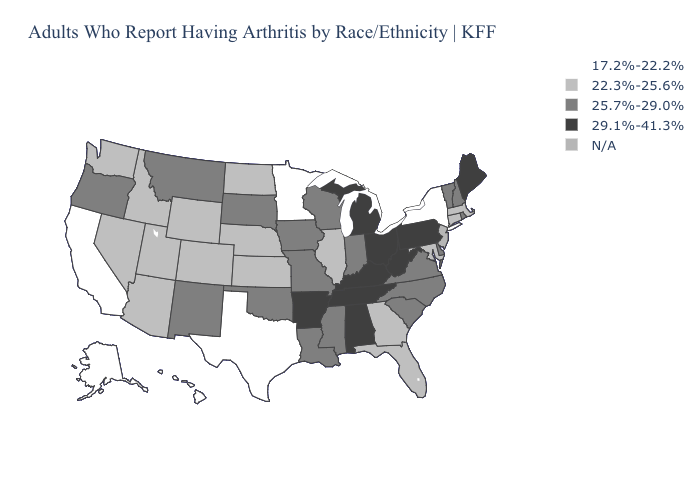Among the states that border Vermont , which have the lowest value?
Answer briefly. New York. Which states hav the highest value in the MidWest?
Quick response, please. Michigan, Ohio. Which states hav the highest value in the South?
Keep it brief. Alabama, Arkansas, Kentucky, Tennessee, West Virginia. What is the highest value in the USA?
Give a very brief answer. 29.1%-41.3%. Is the legend a continuous bar?
Quick response, please. No. Name the states that have a value in the range 29.1%-41.3%?
Short answer required. Alabama, Arkansas, Kentucky, Maine, Michigan, Ohio, Pennsylvania, Tennessee, West Virginia. What is the lowest value in the South?
Concise answer only. 17.2%-22.2%. Name the states that have a value in the range N/A?
Give a very brief answer. New Jersey. Name the states that have a value in the range 25.7%-29.0%?
Quick response, please. Delaware, Indiana, Iowa, Louisiana, Mississippi, Missouri, Montana, New Hampshire, New Mexico, North Carolina, Oklahoma, Oregon, Rhode Island, South Carolina, South Dakota, Vermont, Virginia, Wisconsin. What is the value of North Carolina?
Be succinct. 25.7%-29.0%. Is the legend a continuous bar?
Short answer required. No. What is the value of Oregon?
Concise answer only. 25.7%-29.0%. Does Nevada have the highest value in the USA?
Keep it brief. No. Name the states that have a value in the range 25.7%-29.0%?
Concise answer only. Delaware, Indiana, Iowa, Louisiana, Mississippi, Missouri, Montana, New Hampshire, New Mexico, North Carolina, Oklahoma, Oregon, Rhode Island, South Carolina, South Dakota, Vermont, Virginia, Wisconsin. What is the highest value in the MidWest ?
Keep it brief. 29.1%-41.3%. 